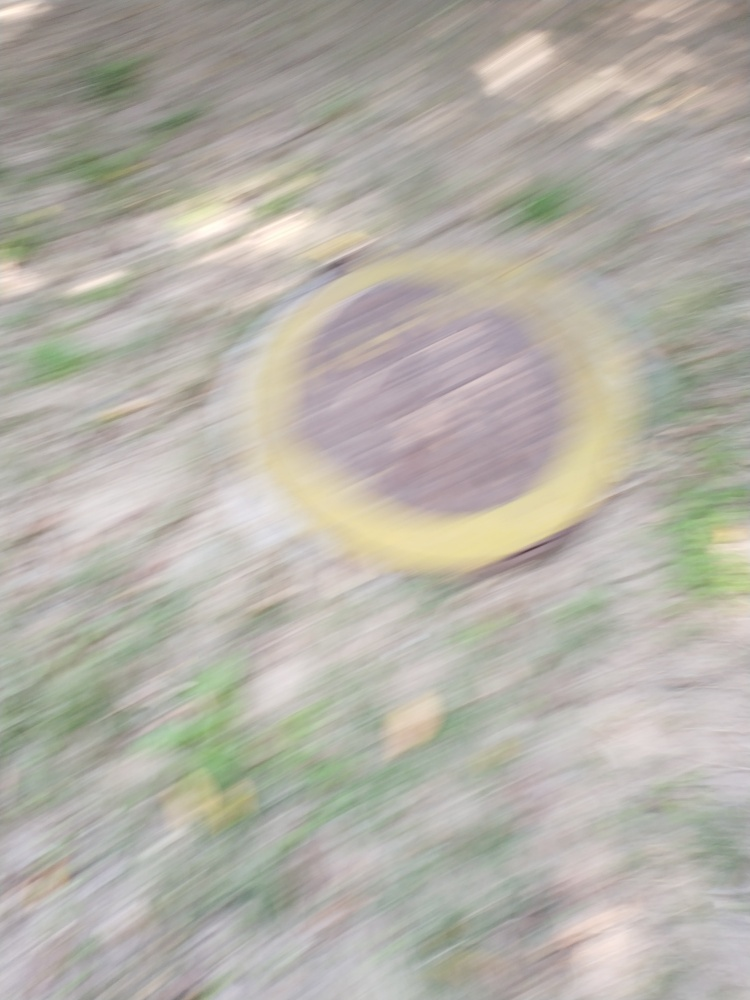Could this image be improved by editing, or would retaking the photo be the best solution? This level of blurriness is challenging to correct via editing because the detail has been substantially obscured. While some sharpening tools can help to a degree, they cannot recreate missing details. Retaking the photo, ensuring proper focus and camera steadiness, would be the most effective solution. 